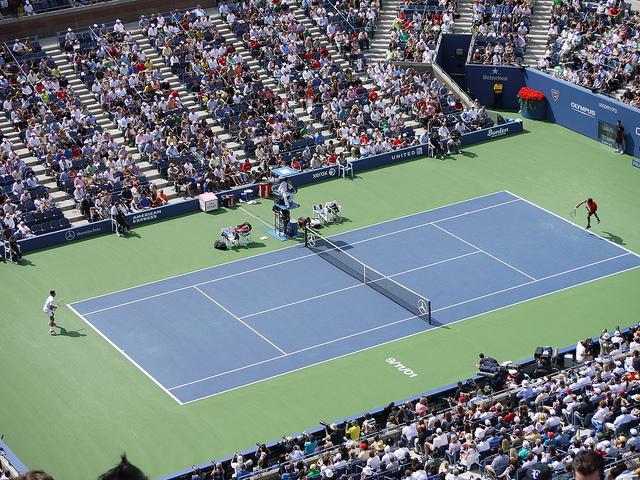Which brand is on the net in the middle of the court?
Be succinct. Mercedes. Are most of the spectator seats filled?
Keep it brief. Yes. How big is the stadium?
Short answer required. Big. 